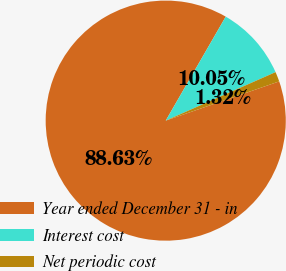Convert chart. <chart><loc_0><loc_0><loc_500><loc_500><pie_chart><fcel>Year ended December 31 - in<fcel>Interest cost<fcel>Net periodic cost<nl><fcel>88.62%<fcel>10.05%<fcel>1.32%<nl></chart> 